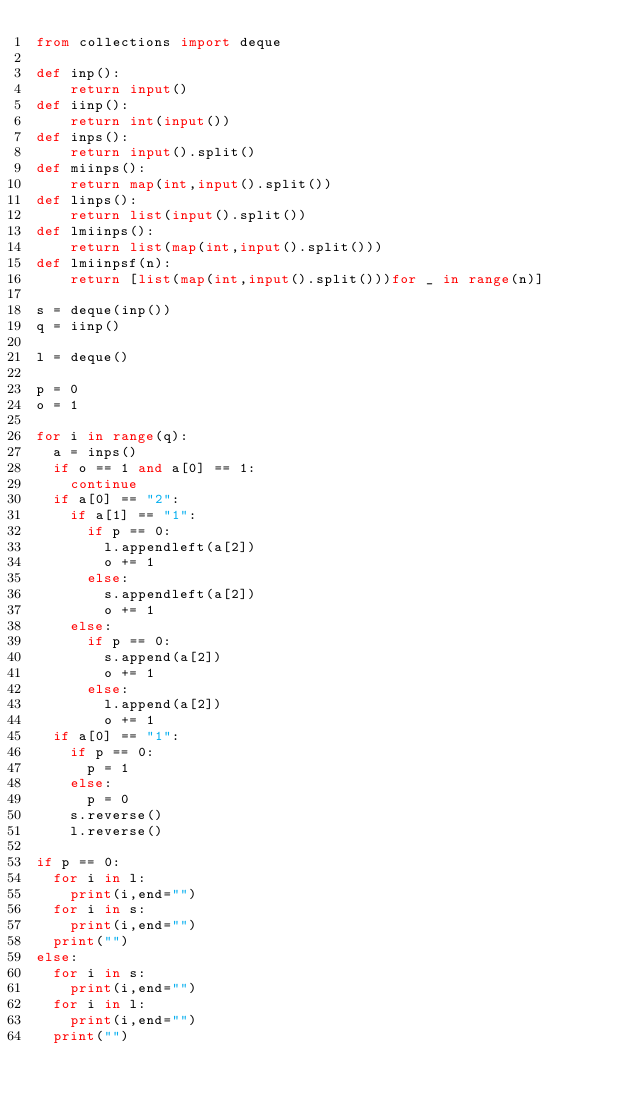Convert code to text. <code><loc_0><loc_0><loc_500><loc_500><_Python_>from collections import deque

def inp():
    return input()
def iinp():
    return int(input())
def inps():
    return input().split()
def miinps():
    return map(int,input().split())
def linps():
    return list(input().split())
def lmiinps():
    return list(map(int,input().split()))
def lmiinpsf(n):
    return [list(map(int,input().split()))for _ in range(n)]

s = deque(inp())
q = iinp()

l = deque()

p = 0
o = 1

for i in range(q):
  a = inps()
  if o == 1 and a[0] == 1:
    continue
  if a[0] == "2":
    if a[1] == "1":
      if p == 0:
        l.appendleft(a[2])
        o += 1
      else:
        s.appendleft(a[2])
        o += 1
    else:
      if p == 0:
        s.append(a[2])
        o += 1
      else:
        l.append(a[2])
        o += 1
  if a[0] == "1":
    if p == 0:
      p = 1
    else:
      p = 0
    s.reverse()
    l.reverse()

if p == 0:
  for i in l:
    print(i,end="")
  for i in s:
    print(i,end="")
  print("")
else:
  for i in s:
    print(i,end="")
  for i in l:
    print(i,end="")
  print("")</code> 